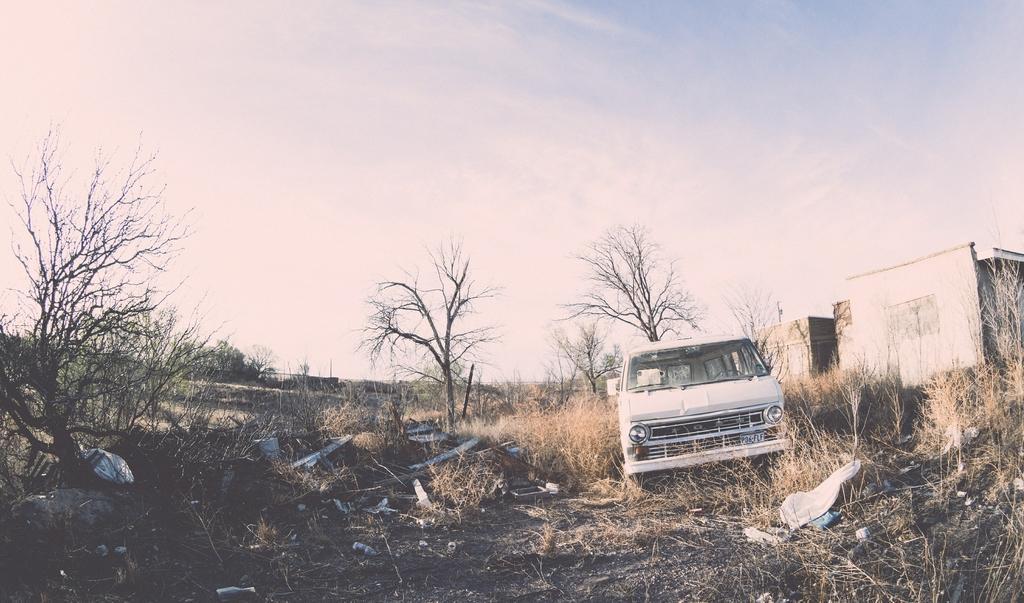Please provide a concise description of this image. In this image I can see dry grass ground and on it I can see number of trees, a white colour vehicle and two buildings. I can also see number of stuffs on the ground. In the background I can see clouds and the sky. 